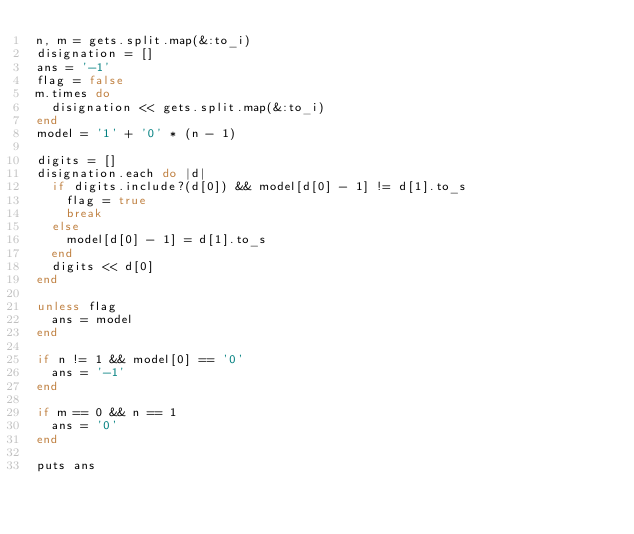Convert code to text. <code><loc_0><loc_0><loc_500><loc_500><_Ruby_>n, m = gets.split.map(&:to_i)
disignation = []
ans = '-1'
flag = false
m.times do
  disignation << gets.split.map(&:to_i)
end
model = '1' + '0' * (n - 1)

digits = []
disignation.each do |d|
  if digits.include?(d[0]) && model[d[0] - 1] != d[1].to_s
    flag = true
    break
  else
    model[d[0] - 1] = d[1].to_s
  end
  digits << d[0]
end

unless flag
  ans = model
end

if n != 1 && model[0] == '0'
  ans = '-1'
end

if m == 0 && n == 1
  ans = '0'
end

puts ans</code> 